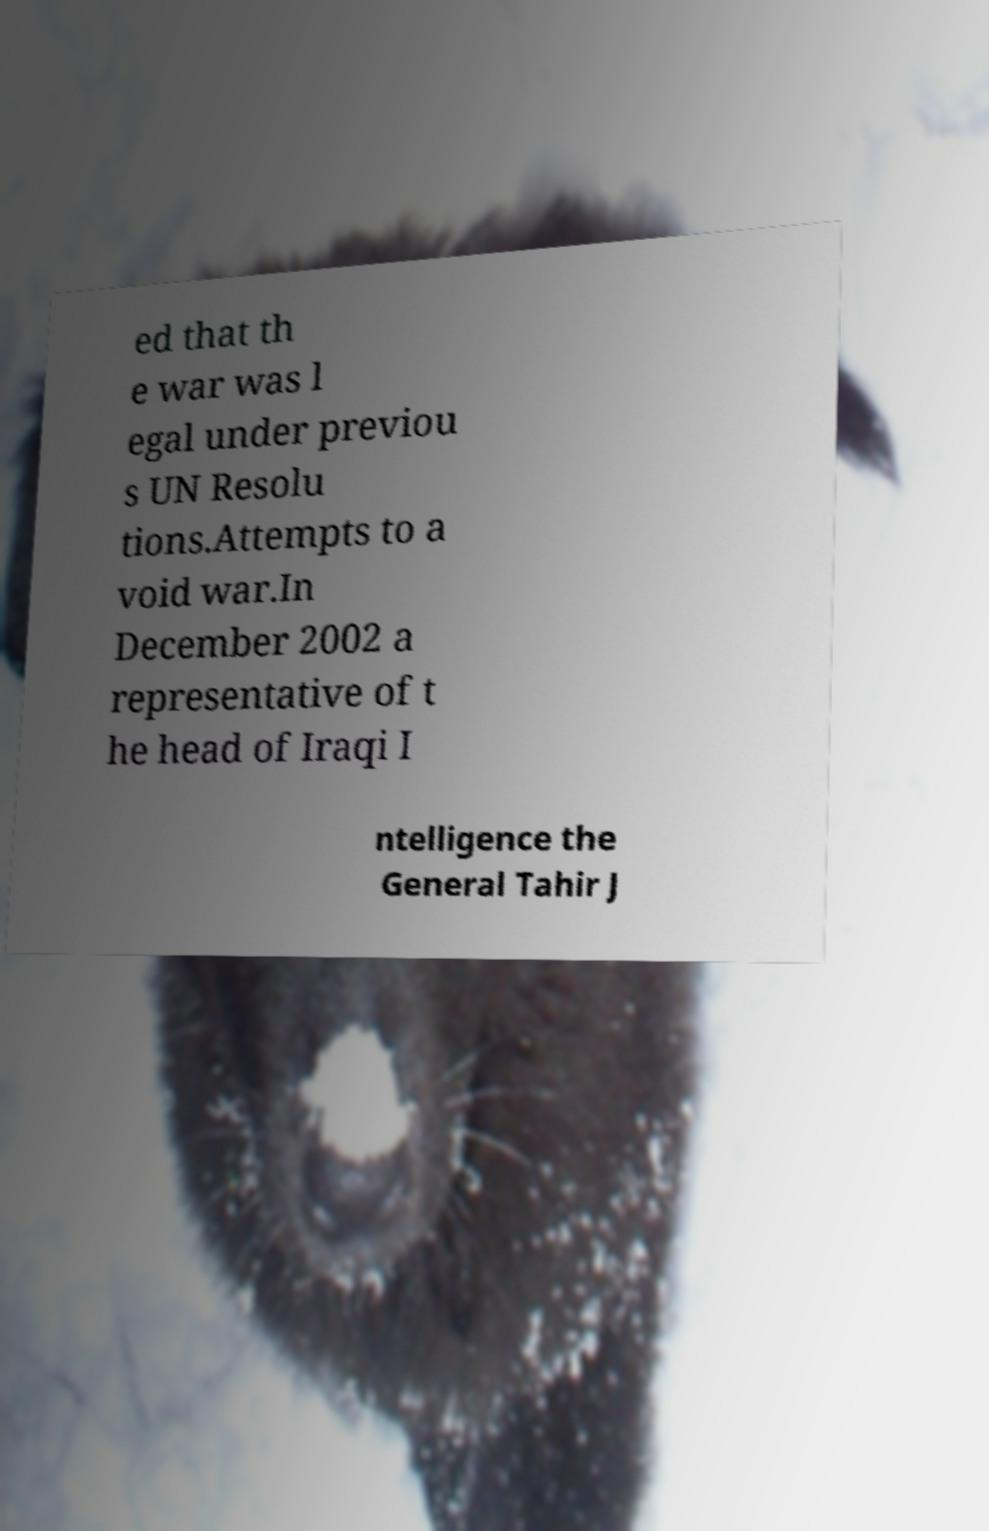For documentation purposes, I need the text within this image transcribed. Could you provide that? ed that th e war was l egal under previou s UN Resolu tions.Attempts to a void war.In December 2002 a representative of t he head of Iraqi I ntelligence the General Tahir J 